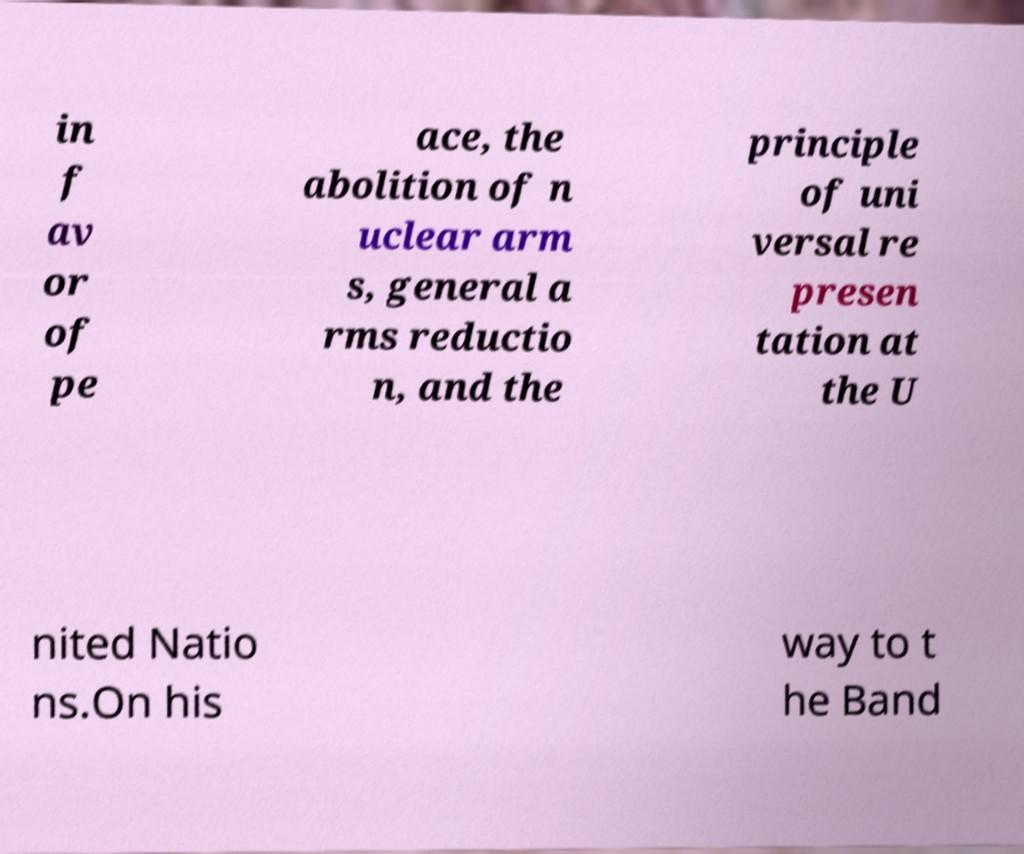There's text embedded in this image that I need extracted. Can you transcribe it verbatim? in f av or of pe ace, the abolition of n uclear arm s, general a rms reductio n, and the principle of uni versal re presen tation at the U nited Natio ns.On his way to t he Band 